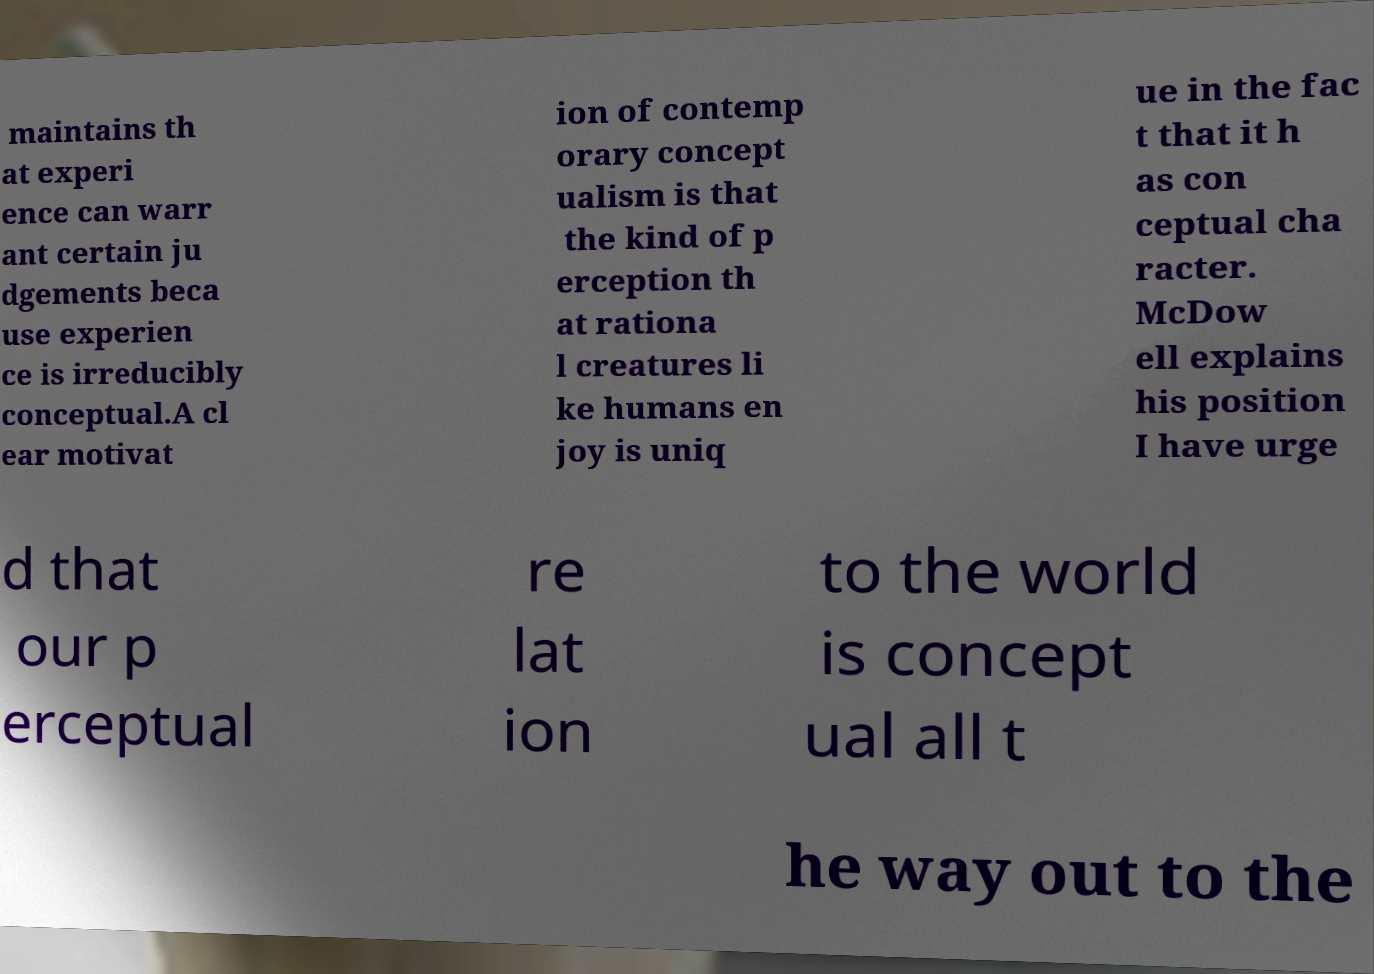Please identify and transcribe the text found in this image. maintains th at experi ence can warr ant certain ju dgements beca use experien ce is irreducibly conceptual.A cl ear motivat ion of contemp orary concept ualism is that the kind of p erception th at rationa l creatures li ke humans en joy is uniq ue in the fac t that it h as con ceptual cha racter. McDow ell explains his position I have urge d that our p erceptual re lat ion to the world is concept ual all t he way out to the 